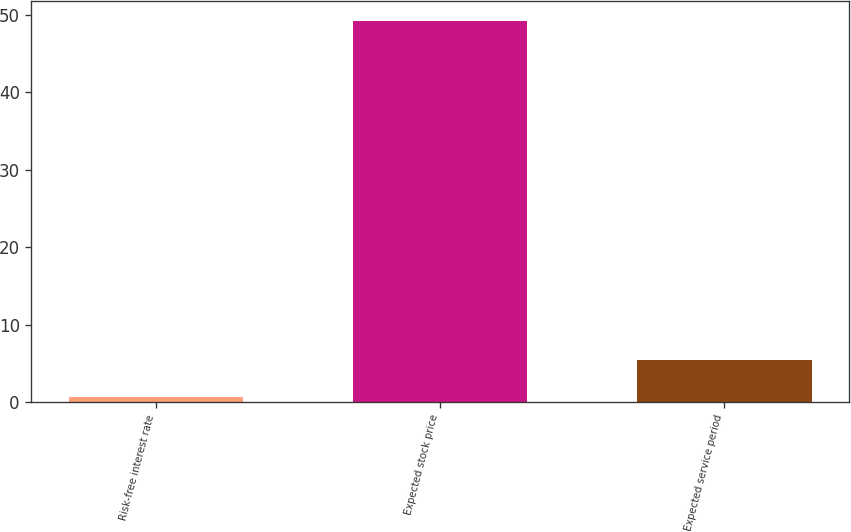<chart> <loc_0><loc_0><loc_500><loc_500><bar_chart><fcel>Risk-free interest rate<fcel>Expected stock price<fcel>Expected service period<nl><fcel>0.6<fcel>49.3<fcel>5.47<nl></chart> 